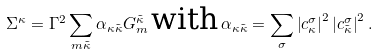Convert formula to latex. <formula><loc_0><loc_0><loc_500><loc_500>\Sigma ^ { \kappa } = \Gamma ^ { 2 } \sum _ { m \tilde { \kappa } } \alpha _ { \kappa \tilde { \kappa } } G _ { m } ^ { \tilde { \kappa } } \, \text {with} \, \alpha _ { \kappa \tilde { \kappa } } = \sum _ { \sigma } \left | c ^ { \sigma } _ { \kappa } \right | ^ { 2 } \left | c ^ { \sigma } _ { \tilde { \kappa } } \right | ^ { 2 } .</formula> 